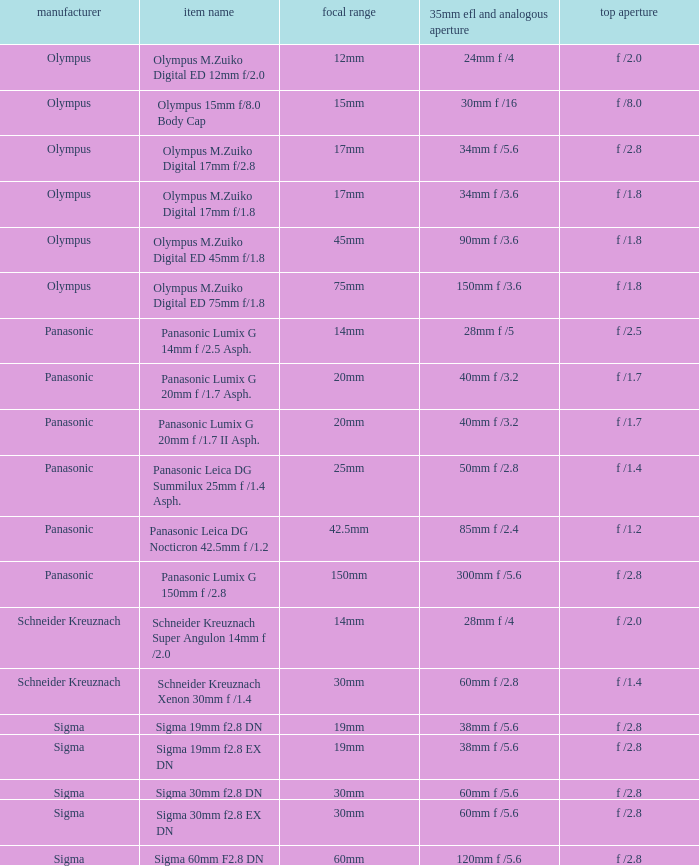What is the maximum aperture of the lens(es) with a focal length of 20mm? F /1.7, f /1.7. 